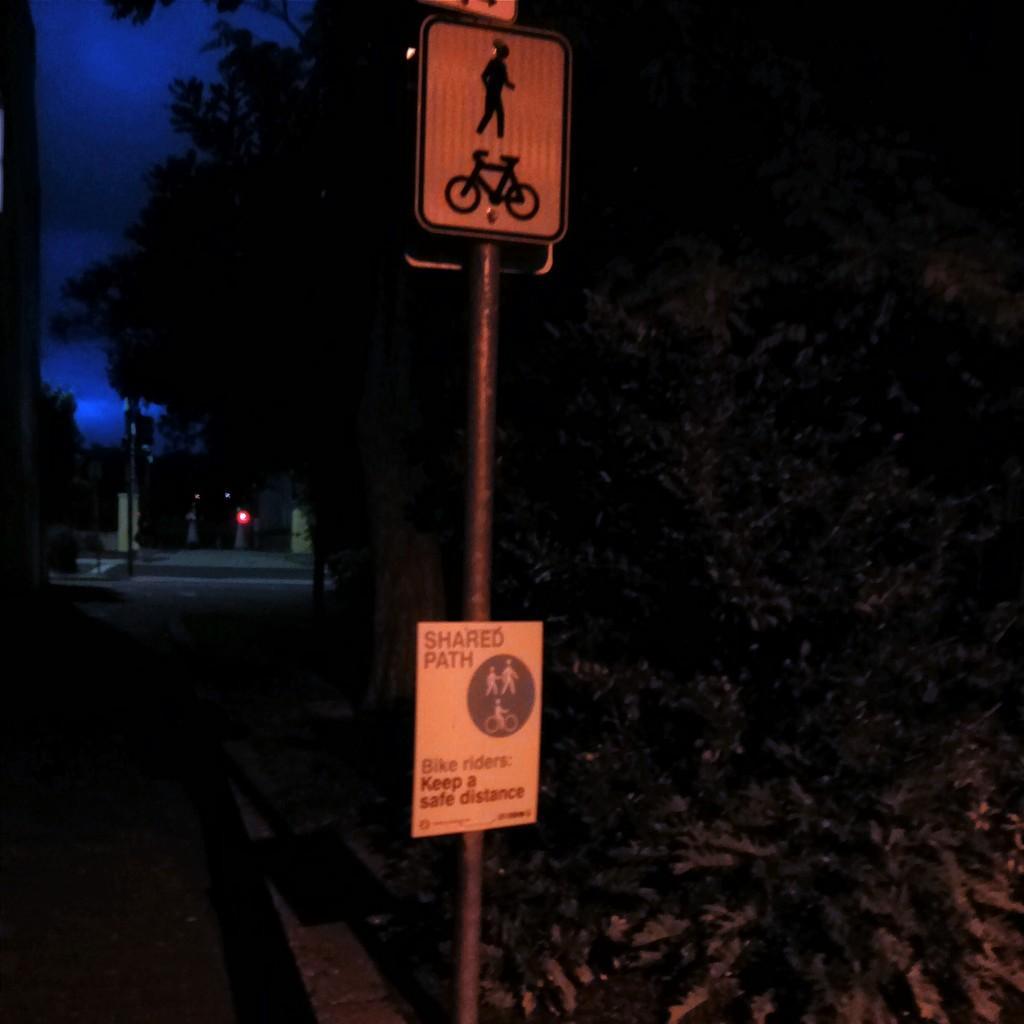Please provide a concise description of this image. In this picture we can see two sign boards attached to the pole and in the background we can see trees, road, sky and some objects. 